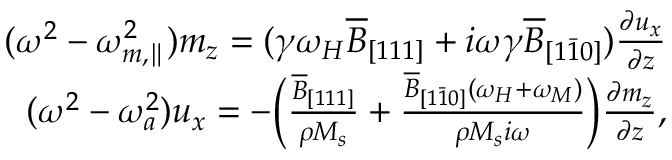<formula> <loc_0><loc_0><loc_500><loc_500>\begin{array} { r } { ( \omega ^ { 2 } - \omega _ { m , \| } ^ { 2 } ) m _ { z } = ( \gamma \omega _ { H } \overline { B } _ { [ 1 1 1 ] } + i \omega \gamma \overline { B } _ { [ 1 \bar { 1 } 0 ] } ) \frac { \partial u _ { x } } { \partial z } } \\ { ( \omega ^ { 2 } - \omega _ { a } ^ { 2 } ) u _ { x } = - \left ( \frac { \overline { B } _ { [ 1 1 1 ] } } { \rho M _ { s } } + \frac { \overline { B } _ { [ 1 \bar { 1 } 0 ] } ( \omega _ { H } + \omega _ { M } ) } { \rho M _ { s } i \omega } \right ) \frac { \partial m _ { z } } { \partial z } , } \end{array}</formula> 